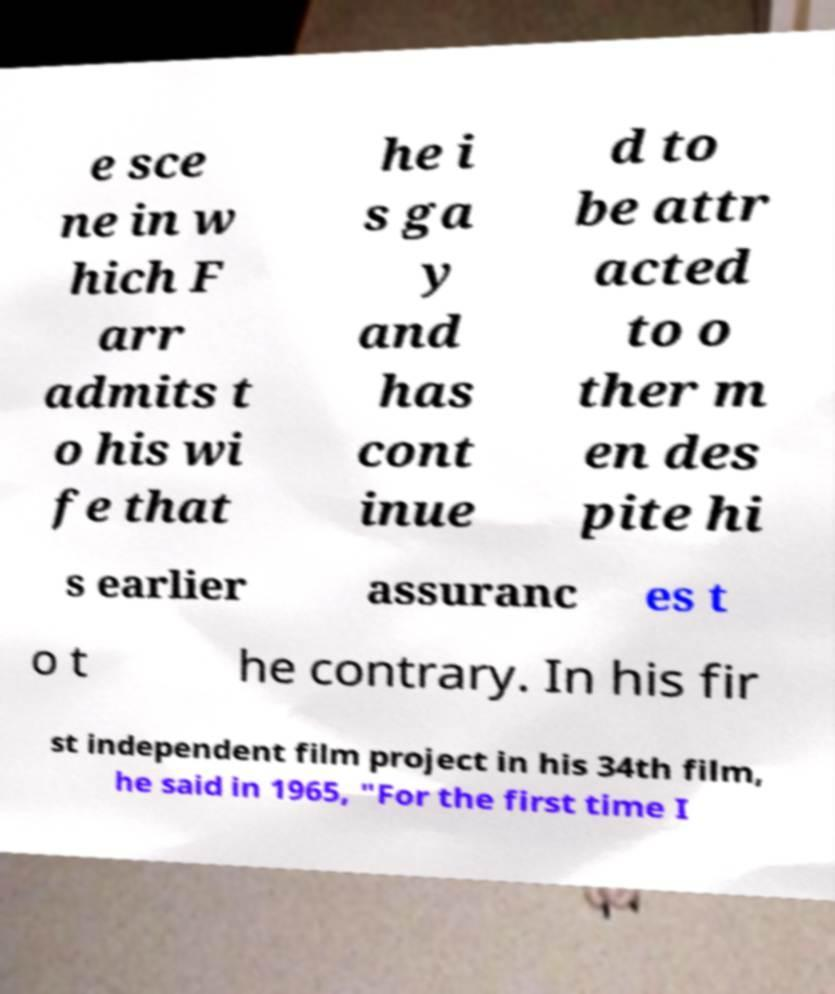Please identify and transcribe the text found in this image. e sce ne in w hich F arr admits t o his wi fe that he i s ga y and has cont inue d to be attr acted to o ther m en des pite hi s earlier assuranc es t o t he contrary. In his fir st independent film project in his 34th film, he said in 1965, "For the first time I 